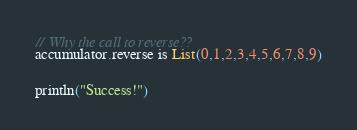<code> <loc_0><loc_0><loc_500><loc_500><_Scala_>
// Why the call to reverse??
accumulator.reverse is List(0,1,2,3,4,5,6,7,8,9)


println("Success!")
</code> 